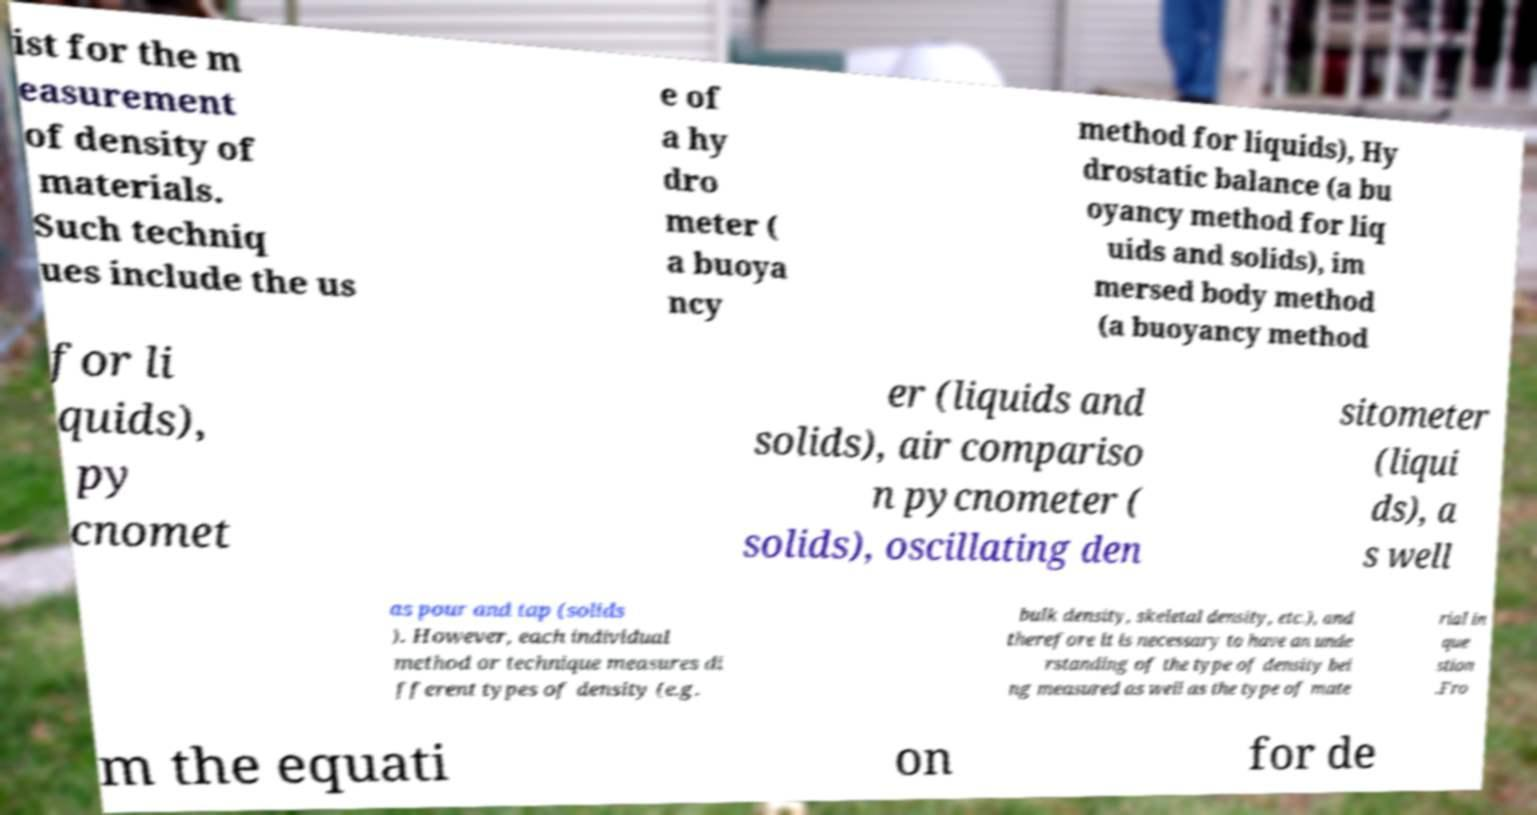I need the written content from this picture converted into text. Can you do that? ist for the m easurement of density of materials. Such techniq ues include the us e of a hy dro meter ( a buoya ncy method for liquids), Hy drostatic balance (a bu oyancy method for liq uids and solids), im mersed body method (a buoyancy method for li quids), py cnomet er (liquids and solids), air compariso n pycnometer ( solids), oscillating den sitometer (liqui ds), a s well as pour and tap (solids ). However, each individual method or technique measures di fferent types of density (e.g. bulk density, skeletal density, etc.), and therefore it is necessary to have an unde rstanding of the type of density bei ng measured as well as the type of mate rial in que stion .Fro m the equati on for de 